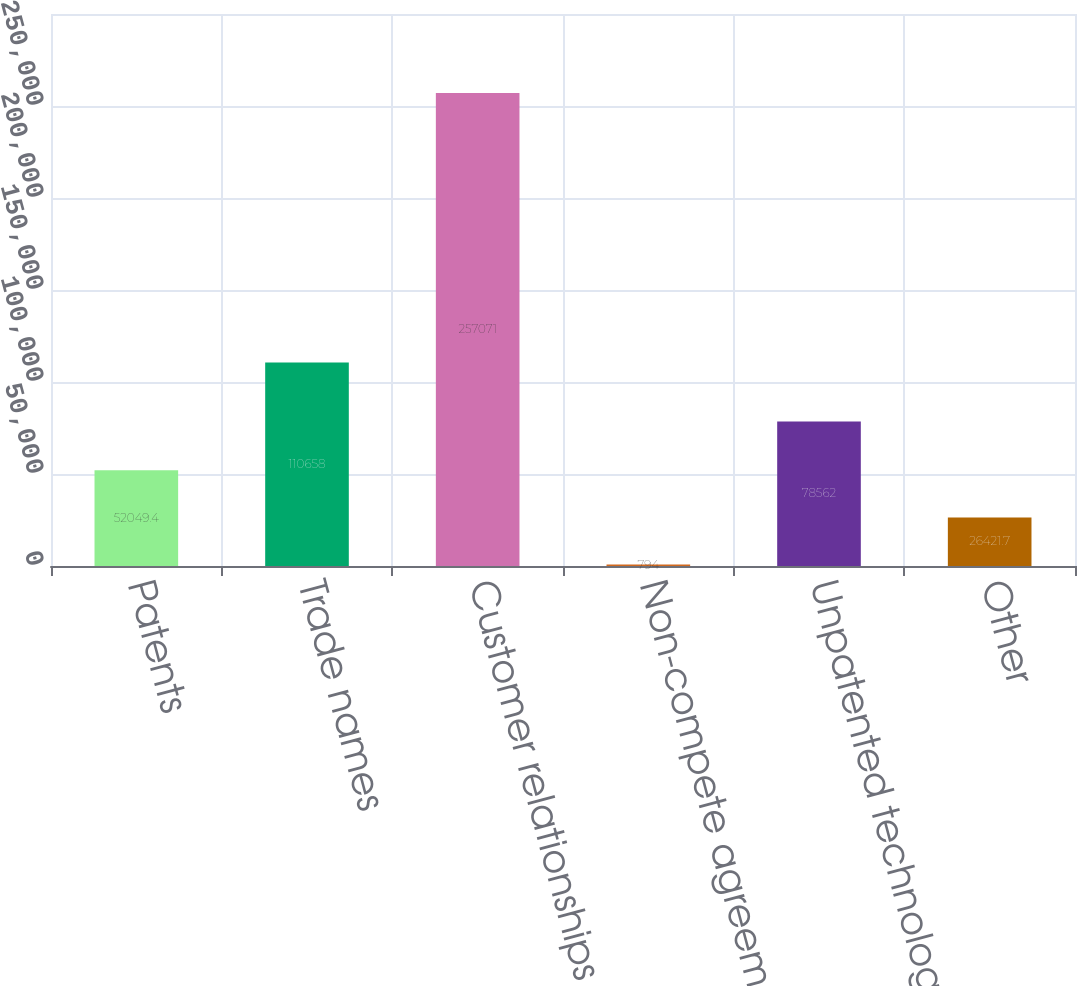Convert chart. <chart><loc_0><loc_0><loc_500><loc_500><bar_chart><fcel>Patents<fcel>Trade names<fcel>Customer relationships<fcel>Non-compete agreements<fcel>Unpatented technology<fcel>Other<nl><fcel>52049.4<fcel>110658<fcel>257071<fcel>794<fcel>78562<fcel>26421.7<nl></chart> 